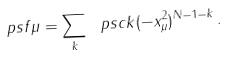<formula> <loc_0><loc_0><loc_500><loc_500>\ p s f { \mu } = \sum _ { k } \ p s c { k } ( - x _ { \mu } ^ { 2 } ) ^ { N { - } 1 { - } k } \, .</formula> 